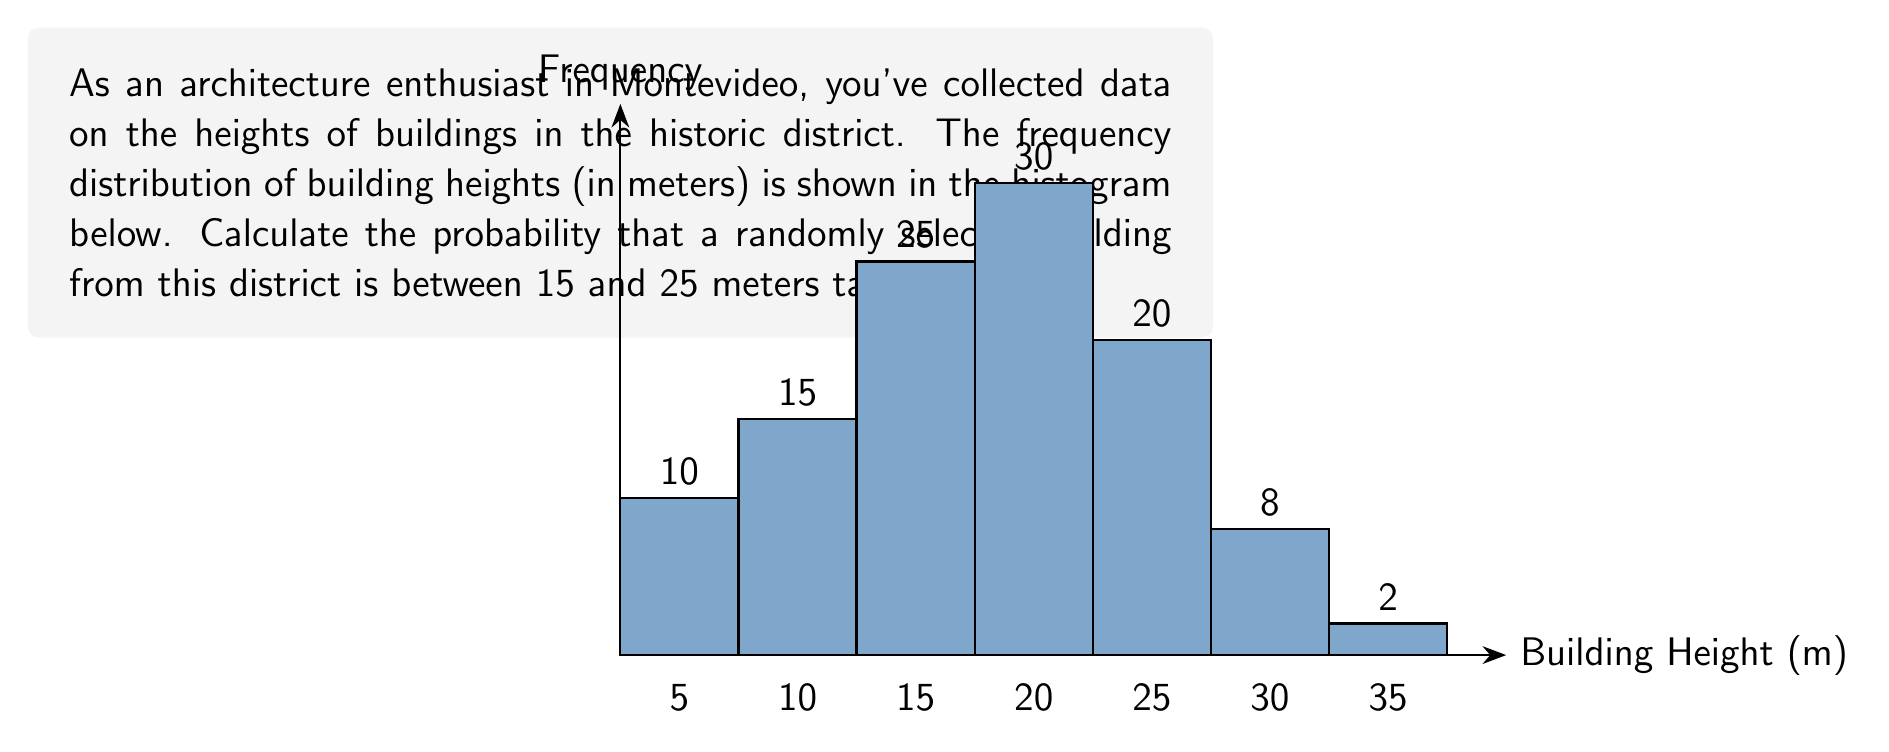Teach me how to tackle this problem. To solve this problem, we'll follow these steps:

1) First, we need to calculate the total number of buildings in the sample:
   $N = 10 + 15 + 25 + 30 + 20 + 8 + 2 = 110$ buildings

2) Next, we identify the bars that represent buildings between 15 and 25 meters:
   - 15-20m bar: 25 buildings
   - 20-25m bar: 30 buildings

3) We sum these frequencies:
   $25 + 30 = 55$ buildings are between 15 and 25 meters tall

4) To calculate the probability, we divide the number of buildings in our desired range by the total number of buildings:

   $$P(15m < height \leq 25m) = \frac{55}{110} = \frac{1}{2} = 0.5$$

Therefore, the probability that a randomly selected building from this district is between 15 and 25 meters tall is 0.5 or 50%.
Answer: 0.5 